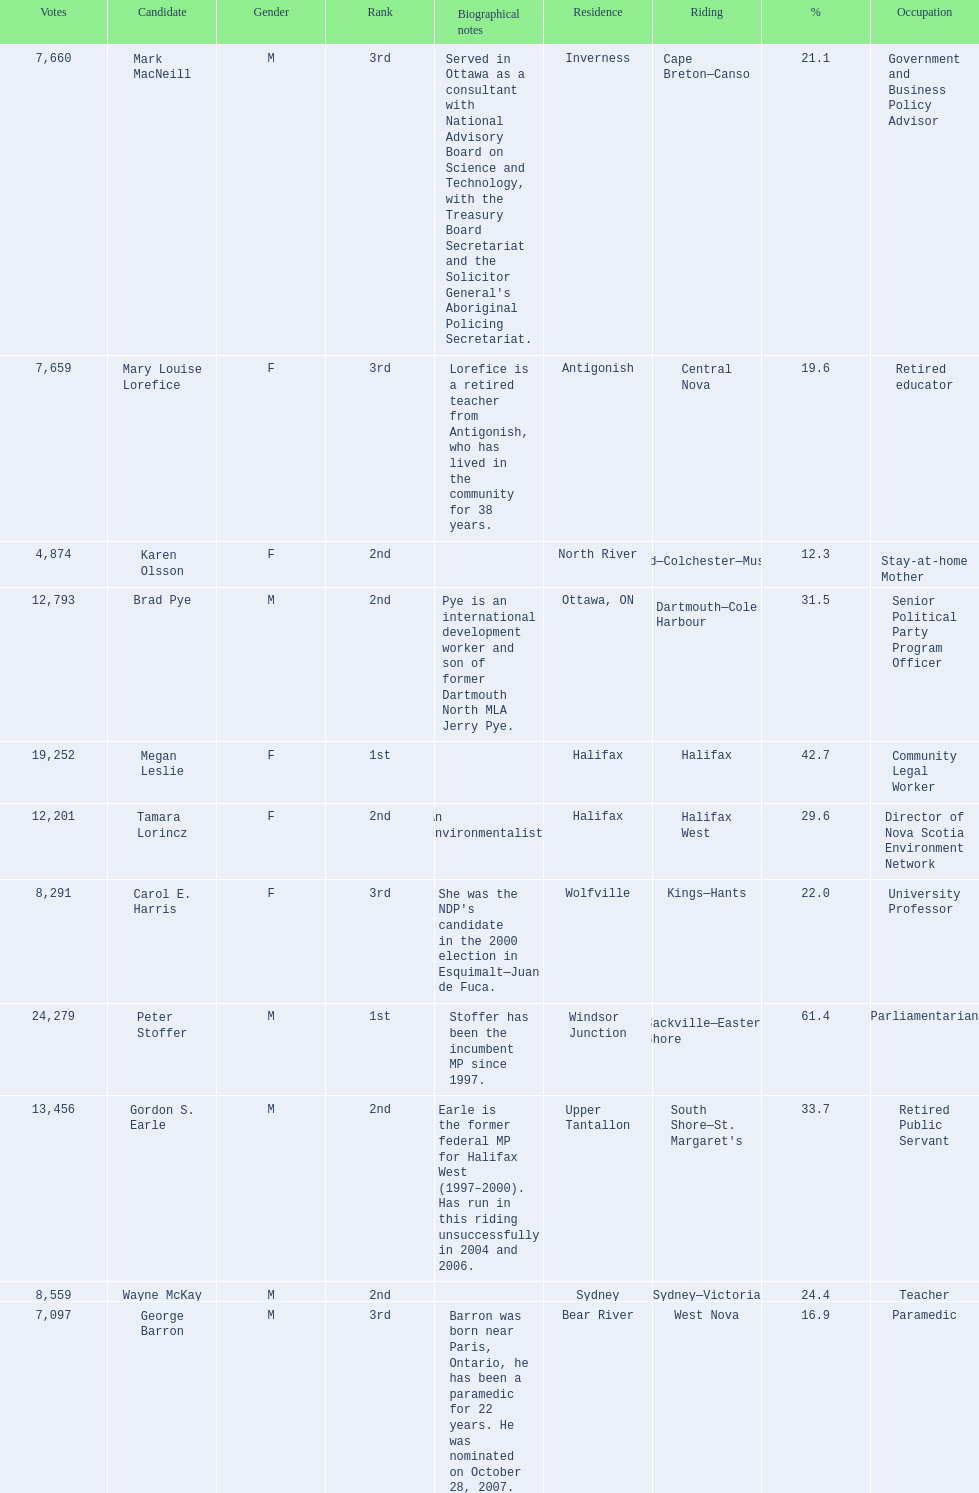Which candidates have the four lowest amount of votes Mark MacNeill, Mary Louise Lorefice, Karen Olsson, George Barron. Out of the following, who has the third most? Mark MacNeill. 